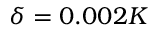<formula> <loc_0><loc_0><loc_500><loc_500>\delta = 0 . 0 0 2 K</formula> 